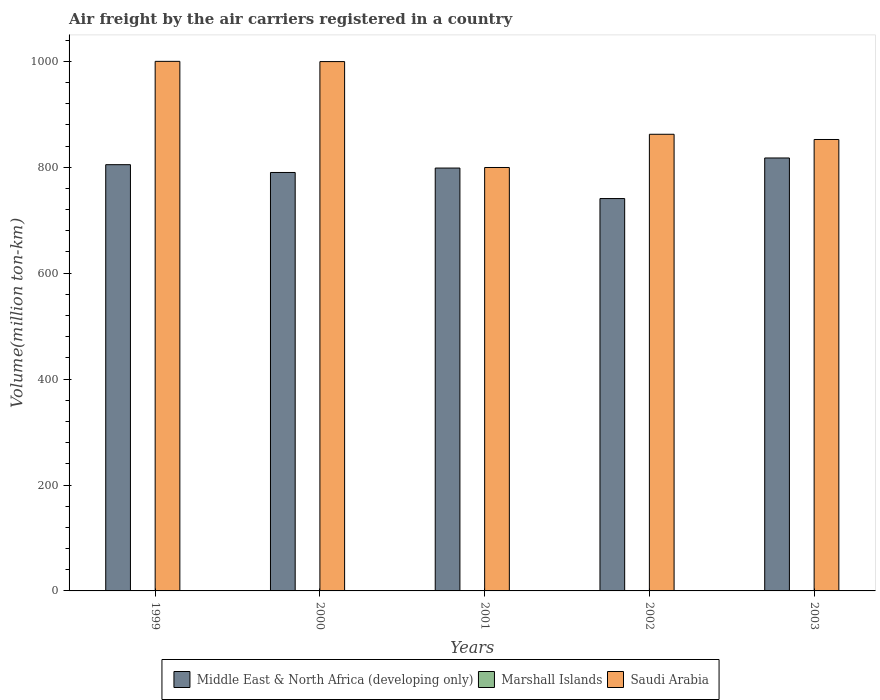How many different coloured bars are there?
Offer a very short reply. 3. How many groups of bars are there?
Your answer should be very brief. 5. Are the number of bars per tick equal to the number of legend labels?
Keep it short and to the point. Yes. Are the number of bars on each tick of the X-axis equal?
Provide a short and direct response. Yes. How many bars are there on the 1st tick from the left?
Your answer should be compact. 3. What is the label of the 5th group of bars from the left?
Provide a short and direct response. 2003. What is the volume of the air carriers in Saudi Arabia in 1999?
Keep it short and to the point. 1000. Across all years, what is the maximum volume of the air carriers in Saudi Arabia?
Your answer should be very brief. 1000. Across all years, what is the minimum volume of the air carriers in Saudi Arabia?
Your answer should be very brief. 799.57. In which year was the volume of the air carriers in Marshall Islands maximum?
Your answer should be very brief. 2003. What is the total volume of the air carriers in Marshall Islands in the graph?
Your answer should be very brief. 1.21. What is the difference between the volume of the air carriers in Marshall Islands in 2001 and that in 2002?
Offer a terse response. -0.11. What is the difference between the volume of the air carriers in Saudi Arabia in 2000 and the volume of the air carriers in Marshall Islands in 2002?
Keep it short and to the point. 999.27. What is the average volume of the air carriers in Saudi Arabia per year?
Your answer should be very brief. 902.77. In the year 2001, what is the difference between the volume of the air carriers in Middle East & North Africa (developing only) and volume of the air carriers in Saudi Arabia?
Provide a succinct answer. -1.06. What is the ratio of the volume of the air carriers in Marshall Islands in 1999 to that in 2001?
Ensure brevity in your answer.  1.09. Is the difference between the volume of the air carriers in Middle East & North Africa (developing only) in 2000 and 2002 greater than the difference between the volume of the air carriers in Saudi Arabia in 2000 and 2002?
Offer a very short reply. No. What is the difference between the highest and the second highest volume of the air carriers in Middle East & North Africa (developing only)?
Give a very brief answer. 12.65. What is the difference between the highest and the lowest volume of the air carriers in Saudi Arabia?
Ensure brevity in your answer.  200.43. Is the sum of the volume of the air carriers in Marshall Islands in 1999 and 2000 greater than the maximum volume of the air carriers in Saudi Arabia across all years?
Offer a very short reply. No. What does the 2nd bar from the left in 2002 represents?
Your answer should be very brief. Marshall Islands. What does the 2nd bar from the right in 2003 represents?
Keep it short and to the point. Marshall Islands. Is it the case that in every year, the sum of the volume of the air carriers in Saudi Arabia and volume of the air carriers in Marshall Islands is greater than the volume of the air carriers in Middle East & North Africa (developing only)?
Keep it short and to the point. Yes. How many bars are there?
Provide a succinct answer. 15. Are all the bars in the graph horizontal?
Ensure brevity in your answer.  No. What is the difference between two consecutive major ticks on the Y-axis?
Offer a terse response. 200. Does the graph contain any zero values?
Offer a terse response. No. Does the graph contain grids?
Give a very brief answer. No. Where does the legend appear in the graph?
Your answer should be very brief. Bottom center. How many legend labels are there?
Offer a very short reply. 3. What is the title of the graph?
Provide a short and direct response. Air freight by the air carriers registered in a country. Does "Seychelles" appear as one of the legend labels in the graph?
Offer a very short reply. No. What is the label or title of the X-axis?
Make the answer very short. Years. What is the label or title of the Y-axis?
Give a very brief answer. Volume(million ton-km). What is the Volume(million ton-km) in Middle East & North Africa (developing only) in 1999?
Keep it short and to the point. 804.9. What is the Volume(million ton-km) of Marshall Islands in 1999?
Your answer should be compact. 0.2. What is the Volume(million ton-km) of Middle East & North Africa (developing only) in 2000?
Ensure brevity in your answer.  790.16. What is the Volume(million ton-km) of Marshall Islands in 2000?
Give a very brief answer. 0.22. What is the Volume(million ton-km) in Saudi Arabia in 2000?
Keep it short and to the point. 999.56. What is the Volume(million ton-km) of Middle East & North Africa (developing only) in 2001?
Your response must be concise. 798.51. What is the Volume(million ton-km) in Marshall Islands in 2001?
Your answer should be compact. 0.18. What is the Volume(million ton-km) in Saudi Arabia in 2001?
Your answer should be compact. 799.57. What is the Volume(million ton-km) of Middle East & North Africa (developing only) in 2002?
Your answer should be compact. 740.92. What is the Volume(million ton-km) in Marshall Islands in 2002?
Provide a short and direct response. 0.29. What is the Volume(million ton-km) in Saudi Arabia in 2002?
Offer a very short reply. 862.29. What is the Volume(million ton-km) in Middle East & North Africa (developing only) in 2003?
Keep it short and to the point. 817.55. What is the Volume(million ton-km) in Marshall Islands in 2003?
Your answer should be compact. 0.31. What is the Volume(million ton-km) in Saudi Arabia in 2003?
Make the answer very short. 852.45. Across all years, what is the maximum Volume(million ton-km) in Middle East & North Africa (developing only)?
Your response must be concise. 817.55. Across all years, what is the maximum Volume(million ton-km) of Marshall Islands?
Offer a very short reply. 0.31. Across all years, what is the maximum Volume(million ton-km) in Saudi Arabia?
Give a very brief answer. 1000. Across all years, what is the minimum Volume(million ton-km) in Middle East & North Africa (developing only)?
Give a very brief answer. 740.92. Across all years, what is the minimum Volume(million ton-km) in Marshall Islands?
Provide a succinct answer. 0.18. Across all years, what is the minimum Volume(million ton-km) of Saudi Arabia?
Make the answer very short. 799.57. What is the total Volume(million ton-km) of Middle East & North Africa (developing only) in the graph?
Your answer should be compact. 3952.03. What is the total Volume(million ton-km) of Marshall Islands in the graph?
Provide a short and direct response. 1.21. What is the total Volume(million ton-km) of Saudi Arabia in the graph?
Your answer should be compact. 4513.86. What is the difference between the Volume(million ton-km) in Middle East & North Africa (developing only) in 1999 and that in 2000?
Your answer should be very brief. 14.74. What is the difference between the Volume(million ton-km) in Marshall Islands in 1999 and that in 2000?
Ensure brevity in your answer.  -0.02. What is the difference between the Volume(million ton-km) in Saudi Arabia in 1999 and that in 2000?
Provide a short and direct response. 0.44. What is the difference between the Volume(million ton-km) in Middle East & North Africa (developing only) in 1999 and that in 2001?
Provide a succinct answer. 6.39. What is the difference between the Volume(million ton-km) in Marshall Islands in 1999 and that in 2001?
Your response must be concise. 0.02. What is the difference between the Volume(million ton-km) of Saudi Arabia in 1999 and that in 2001?
Provide a short and direct response. 200.44. What is the difference between the Volume(million ton-km) of Middle East & North Africa (developing only) in 1999 and that in 2002?
Offer a very short reply. 63.98. What is the difference between the Volume(million ton-km) in Marshall Islands in 1999 and that in 2002?
Make the answer very short. -0.09. What is the difference between the Volume(million ton-km) in Saudi Arabia in 1999 and that in 2002?
Provide a short and direct response. 137.71. What is the difference between the Volume(million ton-km) of Middle East & North Africa (developing only) in 1999 and that in 2003?
Provide a short and direct response. -12.65. What is the difference between the Volume(million ton-km) of Marshall Islands in 1999 and that in 2003?
Provide a short and direct response. -0.11. What is the difference between the Volume(million ton-km) in Saudi Arabia in 1999 and that in 2003?
Provide a short and direct response. 147.55. What is the difference between the Volume(million ton-km) in Middle East & North Africa (developing only) in 2000 and that in 2001?
Offer a very short reply. -8.35. What is the difference between the Volume(million ton-km) of Marshall Islands in 2000 and that in 2001?
Ensure brevity in your answer.  0.04. What is the difference between the Volume(million ton-km) in Saudi Arabia in 2000 and that in 2001?
Make the answer very short. 200. What is the difference between the Volume(million ton-km) in Middle East & North Africa (developing only) in 2000 and that in 2002?
Offer a terse response. 49.24. What is the difference between the Volume(million ton-km) in Marshall Islands in 2000 and that in 2002?
Your answer should be compact. -0.07. What is the difference between the Volume(million ton-km) in Saudi Arabia in 2000 and that in 2002?
Give a very brief answer. 137.27. What is the difference between the Volume(million ton-km) in Middle East & North Africa (developing only) in 2000 and that in 2003?
Make the answer very short. -27.39. What is the difference between the Volume(million ton-km) in Marshall Islands in 2000 and that in 2003?
Offer a very short reply. -0.09. What is the difference between the Volume(million ton-km) of Saudi Arabia in 2000 and that in 2003?
Offer a very short reply. 147.11. What is the difference between the Volume(million ton-km) in Middle East & North Africa (developing only) in 2001 and that in 2002?
Your answer should be compact. 57.58. What is the difference between the Volume(million ton-km) in Marshall Islands in 2001 and that in 2002?
Keep it short and to the point. -0.11. What is the difference between the Volume(million ton-km) in Saudi Arabia in 2001 and that in 2002?
Your answer should be compact. -62.73. What is the difference between the Volume(million ton-km) in Middle East & North Africa (developing only) in 2001 and that in 2003?
Your answer should be compact. -19.04. What is the difference between the Volume(million ton-km) of Marshall Islands in 2001 and that in 2003?
Your answer should be very brief. -0.13. What is the difference between the Volume(million ton-km) of Saudi Arabia in 2001 and that in 2003?
Offer a very short reply. -52.88. What is the difference between the Volume(million ton-km) in Middle East & North Africa (developing only) in 2002 and that in 2003?
Offer a terse response. -76.62. What is the difference between the Volume(million ton-km) of Marshall Islands in 2002 and that in 2003?
Your response must be concise. -0.02. What is the difference between the Volume(million ton-km) of Saudi Arabia in 2002 and that in 2003?
Your answer should be compact. 9.84. What is the difference between the Volume(million ton-km) in Middle East & North Africa (developing only) in 1999 and the Volume(million ton-km) in Marshall Islands in 2000?
Provide a succinct answer. 804.68. What is the difference between the Volume(million ton-km) in Middle East & North Africa (developing only) in 1999 and the Volume(million ton-km) in Saudi Arabia in 2000?
Provide a succinct answer. -194.66. What is the difference between the Volume(million ton-km) in Marshall Islands in 1999 and the Volume(million ton-km) in Saudi Arabia in 2000?
Your answer should be compact. -999.36. What is the difference between the Volume(million ton-km) of Middle East & North Africa (developing only) in 1999 and the Volume(million ton-km) of Marshall Islands in 2001?
Provide a succinct answer. 804.72. What is the difference between the Volume(million ton-km) of Middle East & North Africa (developing only) in 1999 and the Volume(million ton-km) of Saudi Arabia in 2001?
Give a very brief answer. 5.33. What is the difference between the Volume(million ton-km) in Marshall Islands in 1999 and the Volume(million ton-km) in Saudi Arabia in 2001?
Your answer should be very brief. -799.37. What is the difference between the Volume(million ton-km) in Middle East & North Africa (developing only) in 1999 and the Volume(million ton-km) in Marshall Islands in 2002?
Your answer should be compact. 804.61. What is the difference between the Volume(million ton-km) of Middle East & North Africa (developing only) in 1999 and the Volume(million ton-km) of Saudi Arabia in 2002?
Make the answer very short. -57.39. What is the difference between the Volume(million ton-km) of Marshall Islands in 1999 and the Volume(million ton-km) of Saudi Arabia in 2002?
Your answer should be compact. -862.09. What is the difference between the Volume(million ton-km) of Middle East & North Africa (developing only) in 1999 and the Volume(million ton-km) of Marshall Islands in 2003?
Offer a terse response. 804.59. What is the difference between the Volume(million ton-km) of Middle East & North Africa (developing only) in 1999 and the Volume(million ton-km) of Saudi Arabia in 2003?
Provide a short and direct response. -47.55. What is the difference between the Volume(million ton-km) of Marshall Islands in 1999 and the Volume(million ton-km) of Saudi Arabia in 2003?
Your response must be concise. -852.25. What is the difference between the Volume(million ton-km) of Middle East & North Africa (developing only) in 2000 and the Volume(million ton-km) of Marshall Islands in 2001?
Your answer should be compact. 789.98. What is the difference between the Volume(million ton-km) in Middle East & North Africa (developing only) in 2000 and the Volume(million ton-km) in Saudi Arabia in 2001?
Provide a short and direct response. -9.41. What is the difference between the Volume(million ton-km) in Marshall Islands in 2000 and the Volume(million ton-km) in Saudi Arabia in 2001?
Provide a short and direct response. -799.35. What is the difference between the Volume(million ton-km) in Middle East & North Africa (developing only) in 2000 and the Volume(million ton-km) in Marshall Islands in 2002?
Provide a succinct answer. 789.87. What is the difference between the Volume(million ton-km) of Middle East & North Africa (developing only) in 2000 and the Volume(million ton-km) of Saudi Arabia in 2002?
Offer a terse response. -72.13. What is the difference between the Volume(million ton-km) of Marshall Islands in 2000 and the Volume(million ton-km) of Saudi Arabia in 2002?
Provide a short and direct response. -862.07. What is the difference between the Volume(million ton-km) in Middle East & North Africa (developing only) in 2000 and the Volume(million ton-km) in Marshall Islands in 2003?
Provide a short and direct response. 789.85. What is the difference between the Volume(million ton-km) in Middle East & North Africa (developing only) in 2000 and the Volume(million ton-km) in Saudi Arabia in 2003?
Give a very brief answer. -62.29. What is the difference between the Volume(million ton-km) in Marshall Islands in 2000 and the Volume(million ton-km) in Saudi Arabia in 2003?
Give a very brief answer. -852.23. What is the difference between the Volume(million ton-km) of Middle East & North Africa (developing only) in 2001 and the Volume(million ton-km) of Marshall Islands in 2002?
Your answer should be compact. 798.21. What is the difference between the Volume(million ton-km) of Middle East & North Africa (developing only) in 2001 and the Volume(million ton-km) of Saudi Arabia in 2002?
Provide a succinct answer. -63.78. What is the difference between the Volume(million ton-km) in Marshall Islands in 2001 and the Volume(million ton-km) in Saudi Arabia in 2002?
Your answer should be very brief. -862.11. What is the difference between the Volume(million ton-km) of Middle East & North Africa (developing only) in 2001 and the Volume(million ton-km) of Marshall Islands in 2003?
Your answer should be compact. 798.19. What is the difference between the Volume(million ton-km) of Middle East & North Africa (developing only) in 2001 and the Volume(million ton-km) of Saudi Arabia in 2003?
Ensure brevity in your answer.  -53.94. What is the difference between the Volume(million ton-km) of Marshall Islands in 2001 and the Volume(million ton-km) of Saudi Arabia in 2003?
Provide a short and direct response. -852.27. What is the difference between the Volume(million ton-km) of Middle East & North Africa (developing only) in 2002 and the Volume(million ton-km) of Marshall Islands in 2003?
Ensure brevity in your answer.  740.61. What is the difference between the Volume(million ton-km) in Middle East & North Africa (developing only) in 2002 and the Volume(million ton-km) in Saudi Arabia in 2003?
Ensure brevity in your answer.  -111.53. What is the difference between the Volume(million ton-km) of Marshall Islands in 2002 and the Volume(million ton-km) of Saudi Arabia in 2003?
Offer a terse response. -852.16. What is the average Volume(million ton-km) in Middle East & North Africa (developing only) per year?
Your answer should be very brief. 790.41. What is the average Volume(million ton-km) of Marshall Islands per year?
Your answer should be compact. 0.24. What is the average Volume(million ton-km) in Saudi Arabia per year?
Provide a succinct answer. 902.77. In the year 1999, what is the difference between the Volume(million ton-km) of Middle East & North Africa (developing only) and Volume(million ton-km) of Marshall Islands?
Give a very brief answer. 804.7. In the year 1999, what is the difference between the Volume(million ton-km) of Middle East & North Africa (developing only) and Volume(million ton-km) of Saudi Arabia?
Make the answer very short. -195.1. In the year 1999, what is the difference between the Volume(million ton-km) in Marshall Islands and Volume(million ton-km) in Saudi Arabia?
Ensure brevity in your answer.  -999.8. In the year 2000, what is the difference between the Volume(million ton-km) of Middle East & North Africa (developing only) and Volume(million ton-km) of Marshall Islands?
Ensure brevity in your answer.  789.94. In the year 2000, what is the difference between the Volume(million ton-km) in Middle East & North Africa (developing only) and Volume(million ton-km) in Saudi Arabia?
Your answer should be compact. -209.4. In the year 2000, what is the difference between the Volume(million ton-km) of Marshall Islands and Volume(million ton-km) of Saudi Arabia?
Your response must be concise. -999.34. In the year 2001, what is the difference between the Volume(million ton-km) of Middle East & North Africa (developing only) and Volume(million ton-km) of Marshall Islands?
Offer a terse response. 798.32. In the year 2001, what is the difference between the Volume(million ton-km) of Middle East & North Africa (developing only) and Volume(million ton-km) of Saudi Arabia?
Make the answer very short. -1.06. In the year 2001, what is the difference between the Volume(million ton-km) in Marshall Islands and Volume(million ton-km) in Saudi Arabia?
Make the answer very short. -799.38. In the year 2002, what is the difference between the Volume(million ton-km) of Middle East & North Africa (developing only) and Volume(million ton-km) of Marshall Islands?
Your answer should be very brief. 740.63. In the year 2002, what is the difference between the Volume(million ton-km) of Middle East & North Africa (developing only) and Volume(million ton-km) of Saudi Arabia?
Provide a short and direct response. -121.37. In the year 2002, what is the difference between the Volume(million ton-km) in Marshall Islands and Volume(million ton-km) in Saudi Arabia?
Ensure brevity in your answer.  -862. In the year 2003, what is the difference between the Volume(million ton-km) in Middle East & North Africa (developing only) and Volume(million ton-km) in Marshall Islands?
Provide a succinct answer. 817.24. In the year 2003, what is the difference between the Volume(million ton-km) in Middle East & North Africa (developing only) and Volume(million ton-km) in Saudi Arabia?
Offer a terse response. -34.9. In the year 2003, what is the difference between the Volume(million ton-km) in Marshall Islands and Volume(million ton-km) in Saudi Arabia?
Provide a succinct answer. -852.14. What is the ratio of the Volume(million ton-km) of Middle East & North Africa (developing only) in 1999 to that in 2000?
Make the answer very short. 1.02. What is the ratio of the Volume(million ton-km) of Saudi Arabia in 1999 to that in 2000?
Provide a short and direct response. 1. What is the ratio of the Volume(million ton-km) of Middle East & North Africa (developing only) in 1999 to that in 2001?
Provide a succinct answer. 1.01. What is the ratio of the Volume(million ton-km) of Marshall Islands in 1999 to that in 2001?
Ensure brevity in your answer.  1.09. What is the ratio of the Volume(million ton-km) of Saudi Arabia in 1999 to that in 2001?
Offer a terse response. 1.25. What is the ratio of the Volume(million ton-km) in Middle East & North Africa (developing only) in 1999 to that in 2002?
Your answer should be very brief. 1.09. What is the ratio of the Volume(million ton-km) of Marshall Islands in 1999 to that in 2002?
Your answer should be very brief. 0.68. What is the ratio of the Volume(million ton-km) in Saudi Arabia in 1999 to that in 2002?
Your answer should be very brief. 1.16. What is the ratio of the Volume(million ton-km) in Middle East & North Africa (developing only) in 1999 to that in 2003?
Your answer should be very brief. 0.98. What is the ratio of the Volume(million ton-km) in Marshall Islands in 1999 to that in 2003?
Give a very brief answer. 0.64. What is the ratio of the Volume(million ton-km) in Saudi Arabia in 1999 to that in 2003?
Offer a terse response. 1.17. What is the ratio of the Volume(million ton-km) of Middle East & North Africa (developing only) in 2000 to that in 2001?
Offer a very short reply. 0.99. What is the ratio of the Volume(million ton-km) in Marshall Islands in 2000 to that in 2001?
Offer a very short reply. 1.2. What is the ratio of the Volume(million ton-km) in Saudi Arabia in 2000 to that in 2001?
Ensure brevity in your answer.  1.25. What is the ratio of the Volume(million ton-km) of Middle East & North Africa (developing only) in 2000 to that in 2002?
Your answer should be compact. 1.07. What is the ratio of the Volume(million ton-km) in Marshall Islands in 2000 to that in 2002?
Ensure brevity in your answer.  0.75. What is the ratio of the Volume(million ton-km) in Saudi Arabia in 2000 to that in 2002?
Your answer should be compact. 1.16. What is the ratio of the Volume(million ton-km) in Middle East & North Africa (developing only) in 2000 to that in 2003?
Your answer should be compact. 0.97. What is the ratio of the Volume(million ton-km) of Marshall Islands in 2000 to that in 2003?
Provide a short and direct response. 0.71. What is the ratio of the Volume(million ton-km) in Saudi Arabia in 2000 to that in 2003?
Provide a succinct answer. 1.17. What is the ratio of the Volume(million ton-km) in Middle East & North Africa (developing only) in 2001 to that in 2002?
Keep it short and to the point. 1.08. What is the ratio of the Volume(million ton-km) in Marshall Islands in 2001 to that in 2002?
Make the answer very short. 0.63. What is the ratio of the Volume(million ton-km) of Saudi Arabia in 2001 to that in 2002?
Offer a terse response. 0.93. What is the ratio of the Volume(million ton-km) of Middle East & North Africa (developing only) in 2001 to that in 2003?
Your response must be concise. 0.98. What is the ratio of the Volume(million ton-km) in Marshall Islands in 2001 to that in 2003?
Provide a short and direct response. 0.59. What is the ratio of the Volume(million ton-km) of Saudi Arabia in 2001 to that in 2003?
Offer a terse response. 0.94. What is the ratio of the Volume(million ton-km) of Middle East & North Africa (developing only) in 2002 to that in 2003?
Give a very brief answer. 0.91. What is the ratio of the Volume(million ton-km) of Marshall Islands in 2002 to that in 2003?
Provide a succinct answer. 0.94. What is the ratio of the Volume(million ton-km) of Saudi Arabia in 2002 to that in 2003?
Make the answer very short. 1.01. What is the difference between the highest and the second highest Volume(million ton-km) in Middle East & North Africa (developing only)?
Your answer should be very brief. 12.65. What is the difference between the highest and the second highest Volume(million ton-km) of Marshall Islands?
Offer a very short reply. 0.02. What is the difference between the highest and the second highest Volume(million ton-km) of Saudi Arabia?
Your answer should be very brief. 0.44. What is the difference between the highest and the lowest Volume(million ton-km) in Middle East & North Africa (developing only)?
Provide a short and direct response. 76.62. What is the difference between the highest and the lowest Volume(million ton-km) of Marshall Islands?
Provide a succinct answer. 0.13. What is the difference between the highest and the lowest Volume(million ton-km) of Saudi Arabia?
Provide a succinct answer. 200.44. 